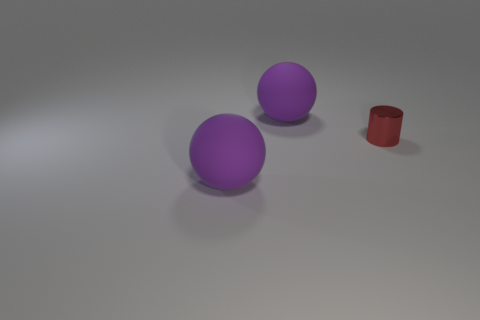Is there any other thing that is made of the same material as the cylinder?
Ensure brevity in your answer.  No. There is a rubber object that is behind the cylinder; does it have the same shape as the purple object that is in front of the red object?
Your answer should be very brief. Yes. How many objects are large gray metal blocks or large purple objects behind the small red metallic object?
Give a very brief answer. 1. What number of purple spheres have the same size as the red cylinder?
Your answer should be very brief. 0. What number of brown things are big cubes or metallic cylinders?
Keep it short and to the point. 0. There is a tiny red object in front of the large purple rubber ball that is behind the small red shiny thing; what shape is it?
Your response must be concise. Cylinder. Is there a tiny metal ball that has the same color as the metallic object?
Your answer should be very brief. No. There is a tiny thing; is it the same shape as the purple matte thing that is behind the cylinder?
Your answer should be very brief. No. What number of other things are made of the same material as the red cylinder?
Offer a very short reply. 0. There is a metal cylinder; are there any large rubber objects on the right side of it?
Give a very brief answer. No. 